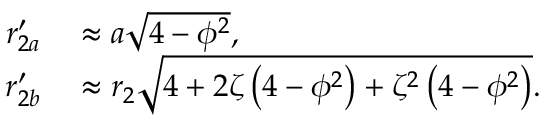Convert formula to latex. <formula><loc_0><loc_0><loc_500><loc_500>\begin{array} { r l } { r _ { 2 a } ^ { \prime } } & \approx a \sqrt { 4 - \phi ^ { 2 } } , } \\ { r _ { 2 b } ^ { \prime } } & \approx r _ { 2 } \sqrt { 4 + 2 \zeta \left ( 4 - \phi ^ { 2 } \right ) + \zeta ^ { 2 } \left ( 4 - \phi ^ { 2 } \right ) } . } \end{array}</formula> 